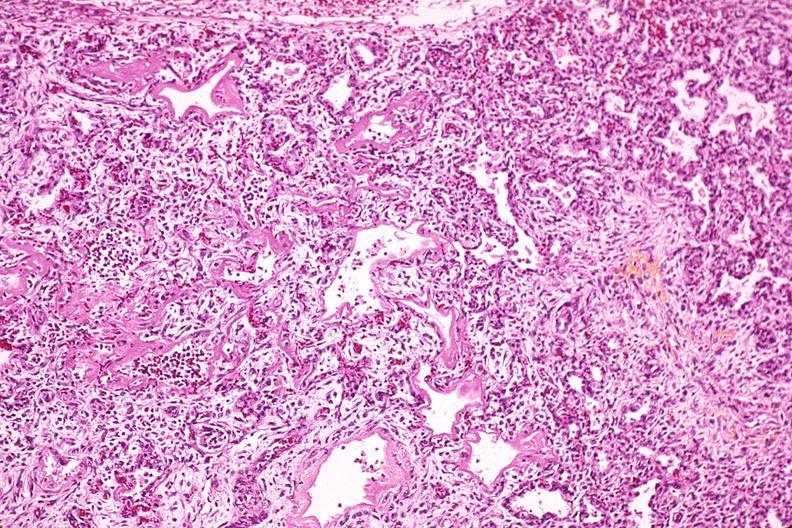does papillary astrocytoma show lung, hyaline membrane disease, yellow discoloration due to hyperbilirubinemia?
Answer the question using a single word or phrase. No 